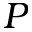<formula> <loc_0><loc_0><loc_500><loc_500>P</formula> 